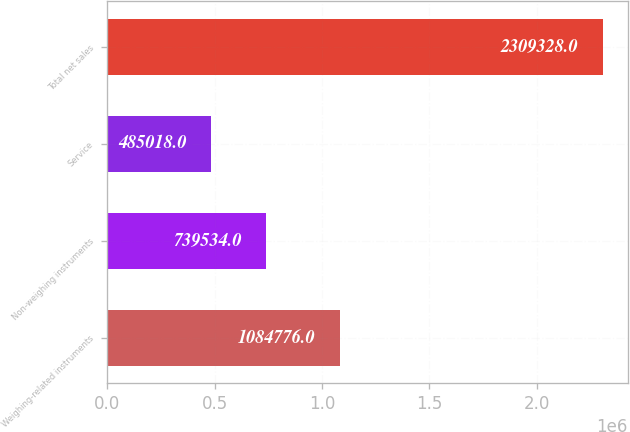Convert chart to OTSL. <chart><loc_0><loc_0><loc_500><loc_500><bar_chart><fcel>Weighing-related instruments<fcel>Non-weighing instruments<fcel>Service<fcel>Total net sales<nl><fcel>1.08478e+06<fcel>739534<fcel>485018<fcel>2.30933e+06<nl></chart> 